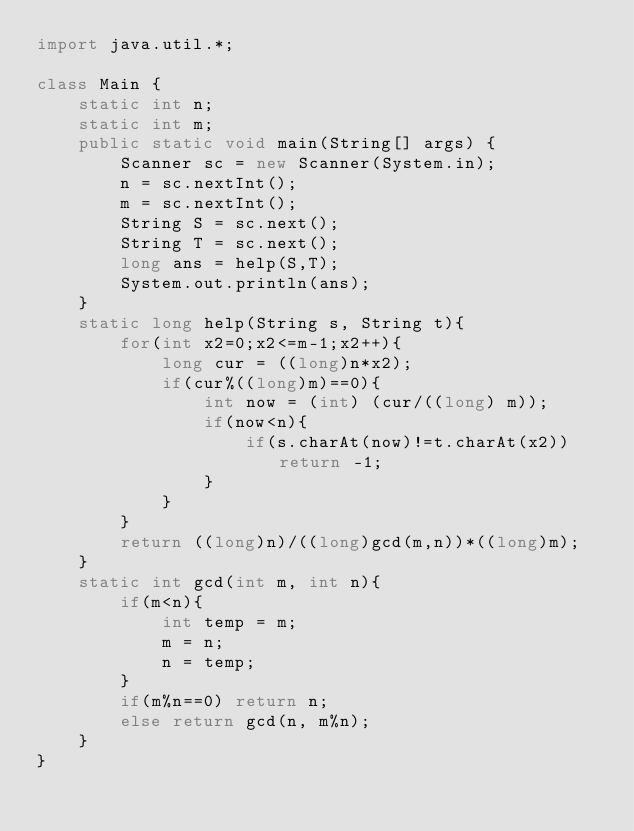<code> <loc_0><loc_0><loc_500><loc_500><_Java_>import java.util.*;

class Main {
    static int n;
    static int m;
    public static void main(String[] args) {
        Scanner sc = new Scanner(System.in);
        n = sc.nextInt();
        m = sc.nextInt();
        String S = sc.next();
        String T = sc.next();
        long ans = help(S,T);
        System.out.println(ans);
    }
    static long help(String s, String t){
        for(int x2=0;x2<=m-1;x2++){
            long cur = ((long)n*x2);
            if(cur%((long)m)==0){
                int now = (int) (cur/((long) m));
                if(now<n){
                    if(s.charAt(now)!=t.charAt(x2)) return -1;
                }
            }
        }
        return ((long)n)/((long)gcd(m,n))*((long)m);
    }
    static int gcd(int m, int n){
        if(m<n){
            int temp = m;
            m = n;
            n = temp;
        }
        if(m%n==0) return n;
        else return gcd(n, m%n);
    }
}
</code> 